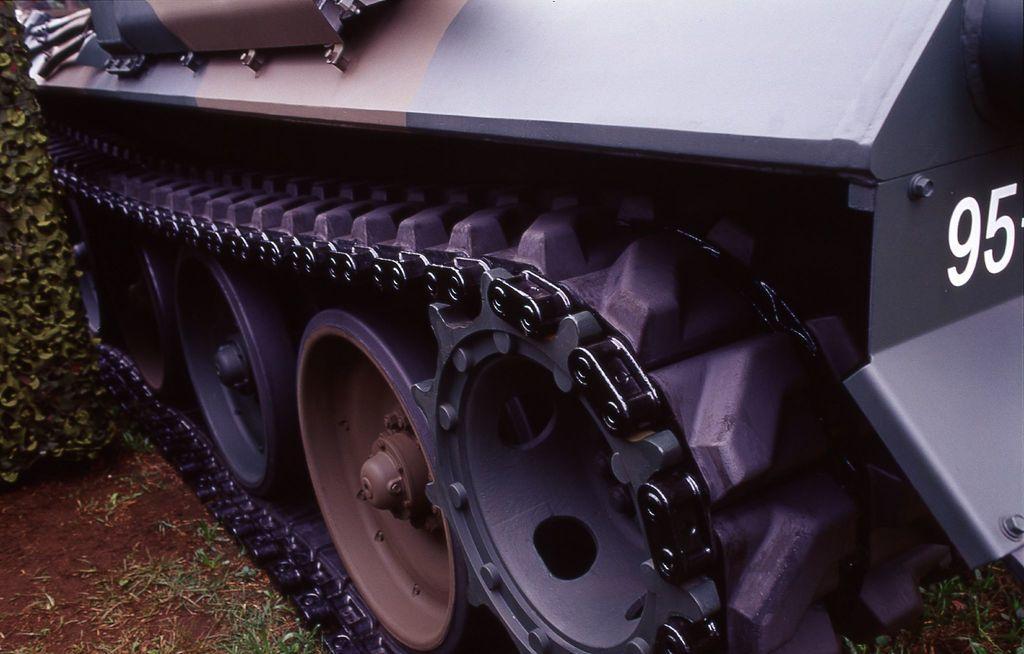Could you give a brief overview of what you see in this image? It is a zoomed in picture of vehicle wheels with the chain. We can also see the numbers on the vehicle. On the left we can see the grass and also the plant and soil. 